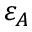<formula> <loc_0><loc_0><loc_500><loc_500>\varepsilon _ { A }</formula> 